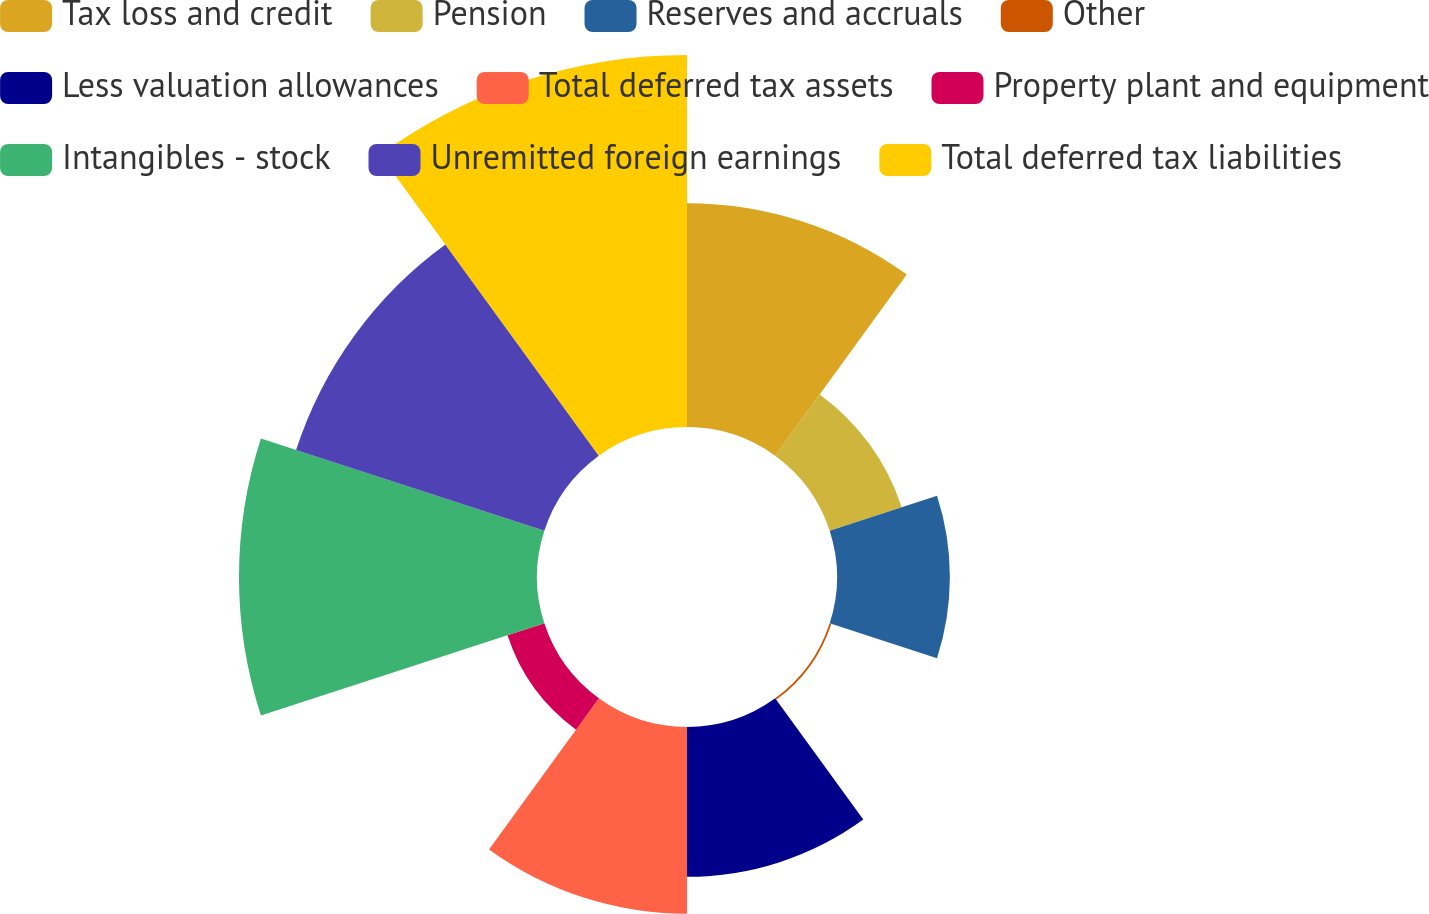Convert chart to OTSL. <chart><loc_0><loc_0><loc_500><loc_500><pie_chart><fcel>Tax loss and credit<fcel>Pension<fcel>Reserves and accruals<fcel>Other<fcel>Less valuation allowances<fcel>Total deferred tax assets<fcel>Property plant and equipment<fcel>Intangibles - stock<fcel>Unremitted foreign earnings<fcel>Total deferred tax liabilities<nl><fcel>13.01%<fcel>4.4%<fcel>6.56%<fcel>0.1%<fcel>8.71%<fcel>10.86%<fcel>2.25%<fcel>17.32%<fcel>15.17%<fcel>21.62%<nl></chart> 